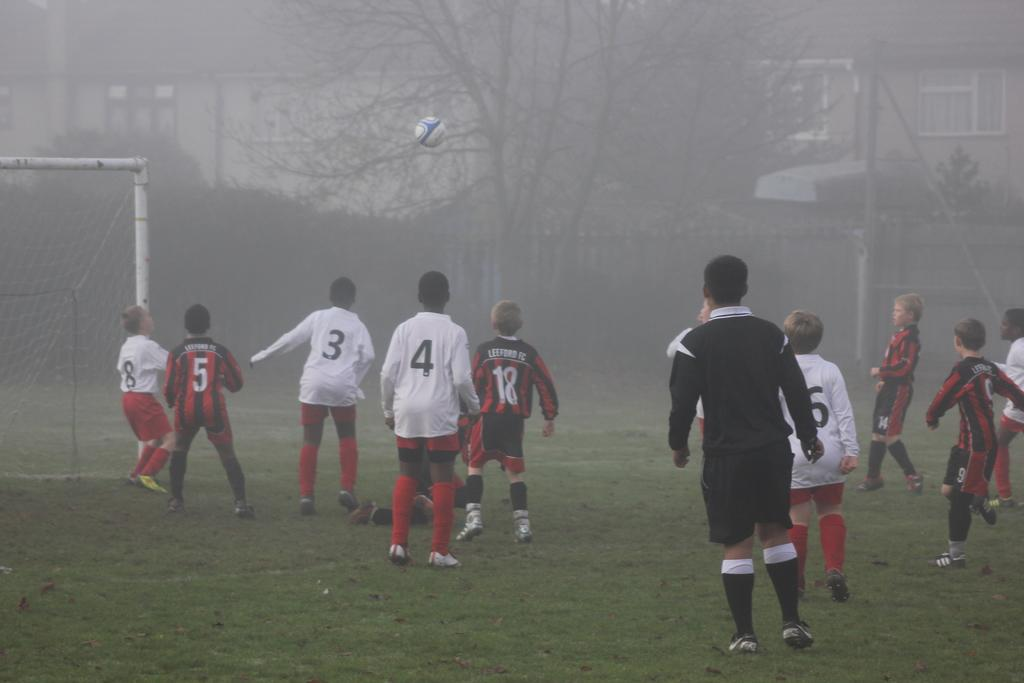Provide a one-sentence caption for the provided image. A youth soccer game with two teams; one of them being Leeford FC. 